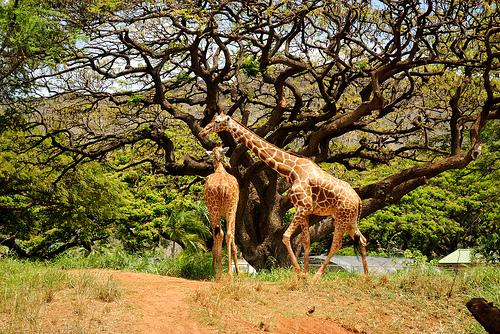Question: why are the animals there?
Choices:
A. Eating.
B. Drinking.
C. Mating.
D. Roaming.
Answer with the letter. Answer: D Question: what is on the tree?
Choices:
A. Nest.
B. Owl.
C. Leaves.
D. Birds.
Answer with the letter. Answer: D Question: how many giraffes?
Choices:
A. 4.
B. 2.
C. 12.
D. 5.
Answer with the letter. Answer: B Question: what is the other giraffe doing?
Choices:
A. Nuzzling.
B. Running.
C. Sitting.
D. Eating.
Answer with the letter. Answer: D 